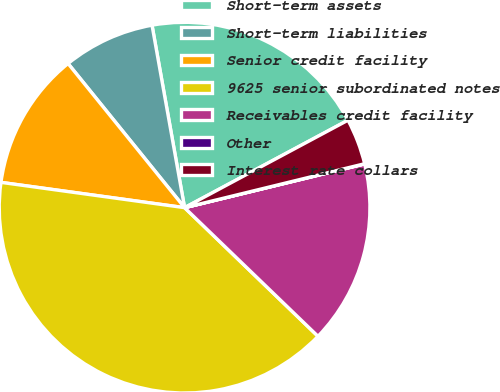Convert chart. <chart><loc_0><loc_0><loc_500><loc_500><pie_chart><fcel>Short-term assets<fcel>Short-term liabilities<fcel>Senior credit facility<fcel>9625 senior subordinated notes<fcel>Receivables credit facility<fcel>Other<fcel>Interest rate collars<nl><fcel>19.99%<fcel>8.01%<fcel>12.0%<fcel>39.97%<fcel>16.0%<fcel>0.02%<fcel>4.01%<nl></chart> 